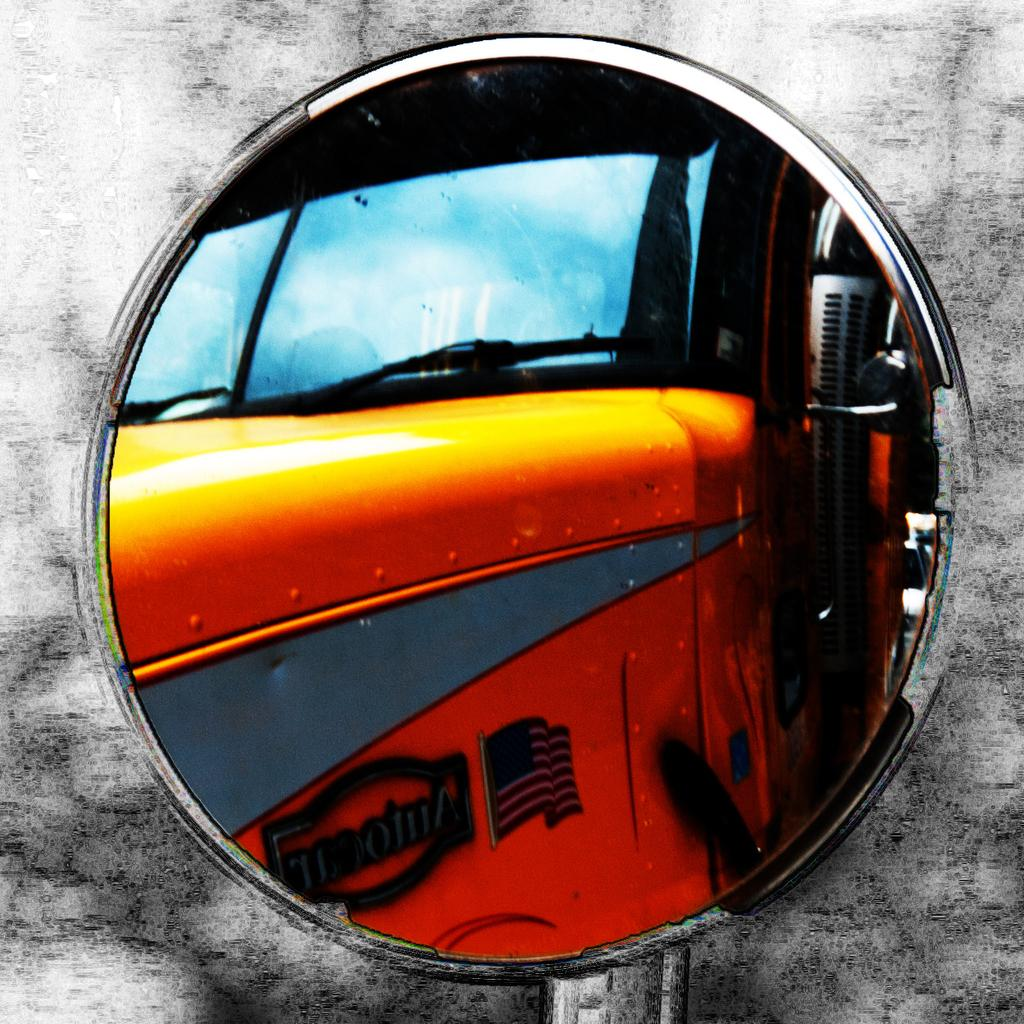What object is present in the image that allows for reflection? There is a mirror in the image. What can be seen through the mirror in the image? A yellow color vehicle is visible through the mirror. What is the condition of the sky in the image? The sky in the image has clouds. What colors are used in the background of the image? The background of the image is in white and black color. Can you tell me how many actors are sleeping in the image? There are no actors or sleeping individuals present in the image. What type of yoke is attached to the vehicle seen through the mirror? There is no yoke visible in the image, as it only shows a mirror and a yellow color vehicle. 